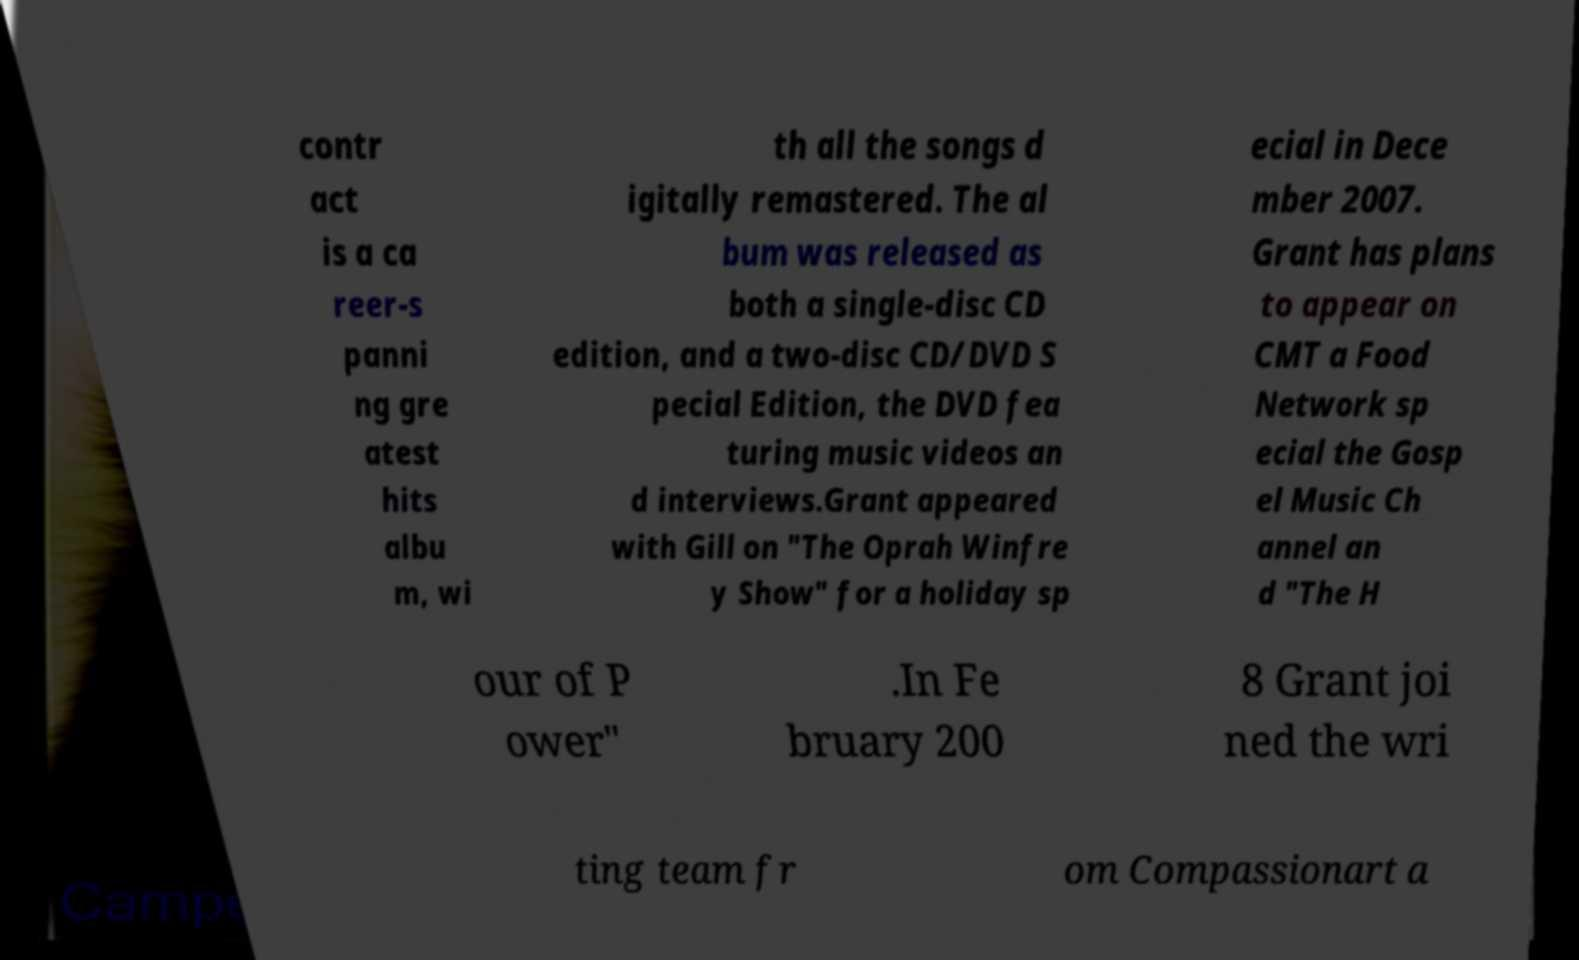Can you read and provide the text displayed in the image?This photo seems to have some interesting text. Can you extract and type it out for me? contr act is a ca reer-s panni ng gre atest hits albu m, wi th all the songs d igitally remastered. The al bum was released as both a single-disc CD edition, and a two-disc CD/DVD S pecial Edition, the DVD fea turing music videos an d interviews.Grant appeared with Gill on "The Oprah Winfre y Show" for a holiday sp ecial in Dece mber 2007. Grant has plans to appear on CMT a Food Network sp ecial the Gosp el Music Ch annel an d "The H our of P ower" .In Fe bruary 200 8 Grant joi ned the wri ting team fr om Compassionart a 